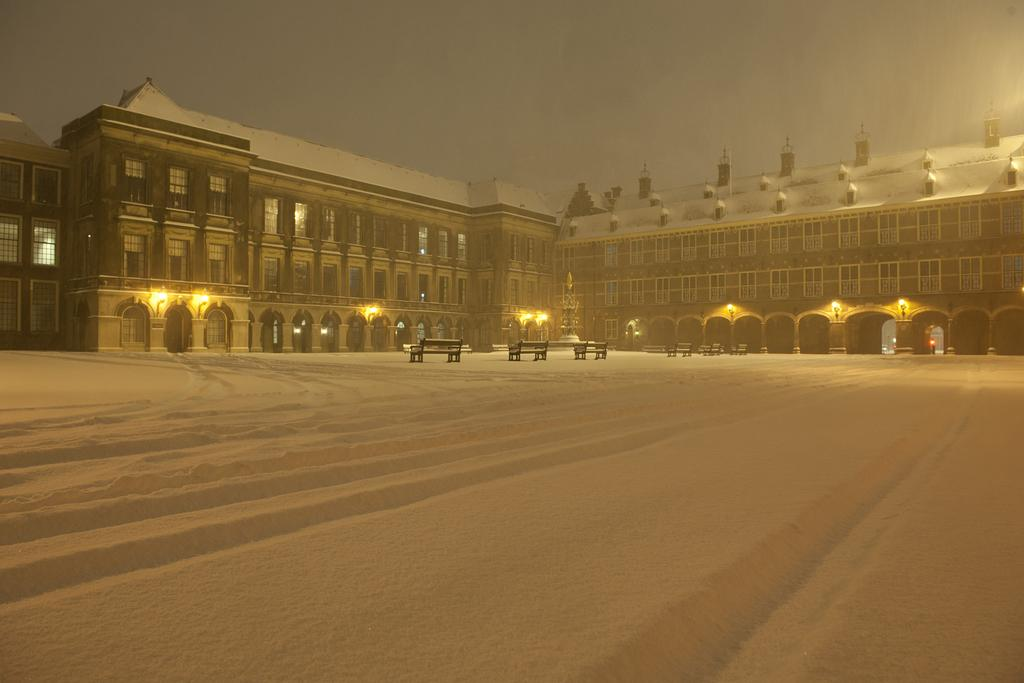What type of seating is present in the image? There are benches in the image. What can be seen in the background of the image? There is a building in the background of the image. What colors are present on the building? The building has brown and white colors. What is illuminated in the image? There are lights visible in the image. How would you describe the color of the sky in the image? The sky has a white and blue color. What type of wine is being served at the thrilling event happening near the benches in the image? There is no mention of wine or any event in the image; it only features benches, a building, lights, and the sky. Is there a coat visible on any of the benches in the image? There is no coat visible on any of the benches in the image. 